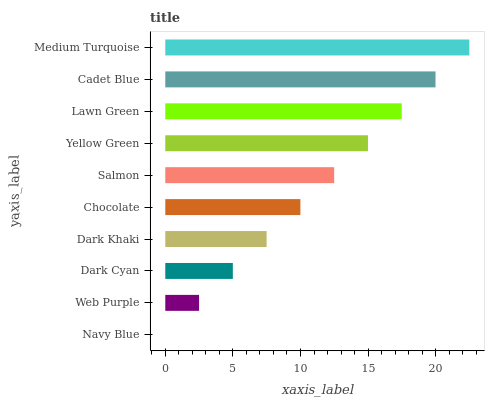Is Navy Blue the minimum?
Answer yes or no. Yes. Is Medium Turquoise the maximum?
Answer yes or no. Yes. Is Web Purple the minimum?
Answer yes or no. No. Is Web Purple the maximum?
Answer yes or no. No. Is Web Purple greater than Navy Blue?
Answer yes or no. Yes. Is Navy Blue less than Web Purple?
Answer yes or no. Yes. Is Navy Blue greater than Web Purple?
Answer yes or no. No. Is Web Purple less than Navy Blue?
Answer yes or no. No. Is Salmon the high median?
Answer yes or no. Yes. Is Chocolate the low median?
Answer yes or no. Yes. Is Navy Blue the high median?
Answer yes or no. No. Is Dark Khaki the low median?
Answer yes or no. No. 